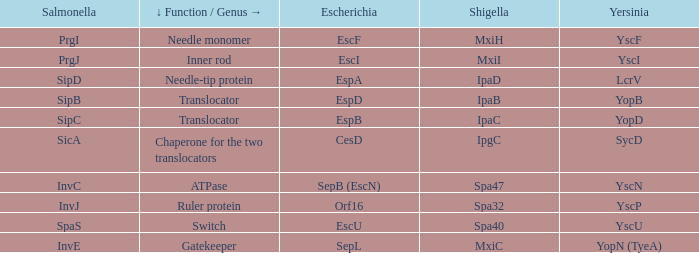Tell me the shigella and yscn Spa47. 